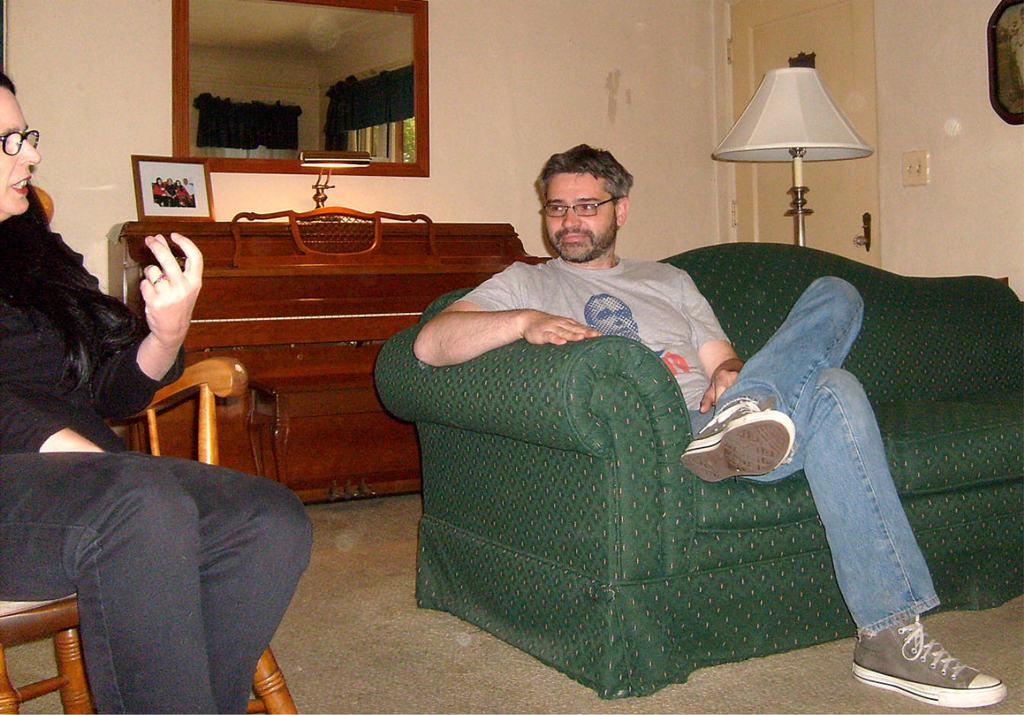What is the person on the left side of the image sitting on? There is a person sitting on a green sofa. Who is sitting next to the person on the sofa? There is another person sitting in a chair beside the person on the sofa. What object in the scene might be used for reflecting images? There is a mirror in the scene. What type of furniture is present in the scene besides the sofa and chair? There is a wooden table in the scene. What type of juice is being served to the children in the image? There are no children or juice present in the image. Is there a rat hiding under the wooden table in the image? There is no rat present in the image. 